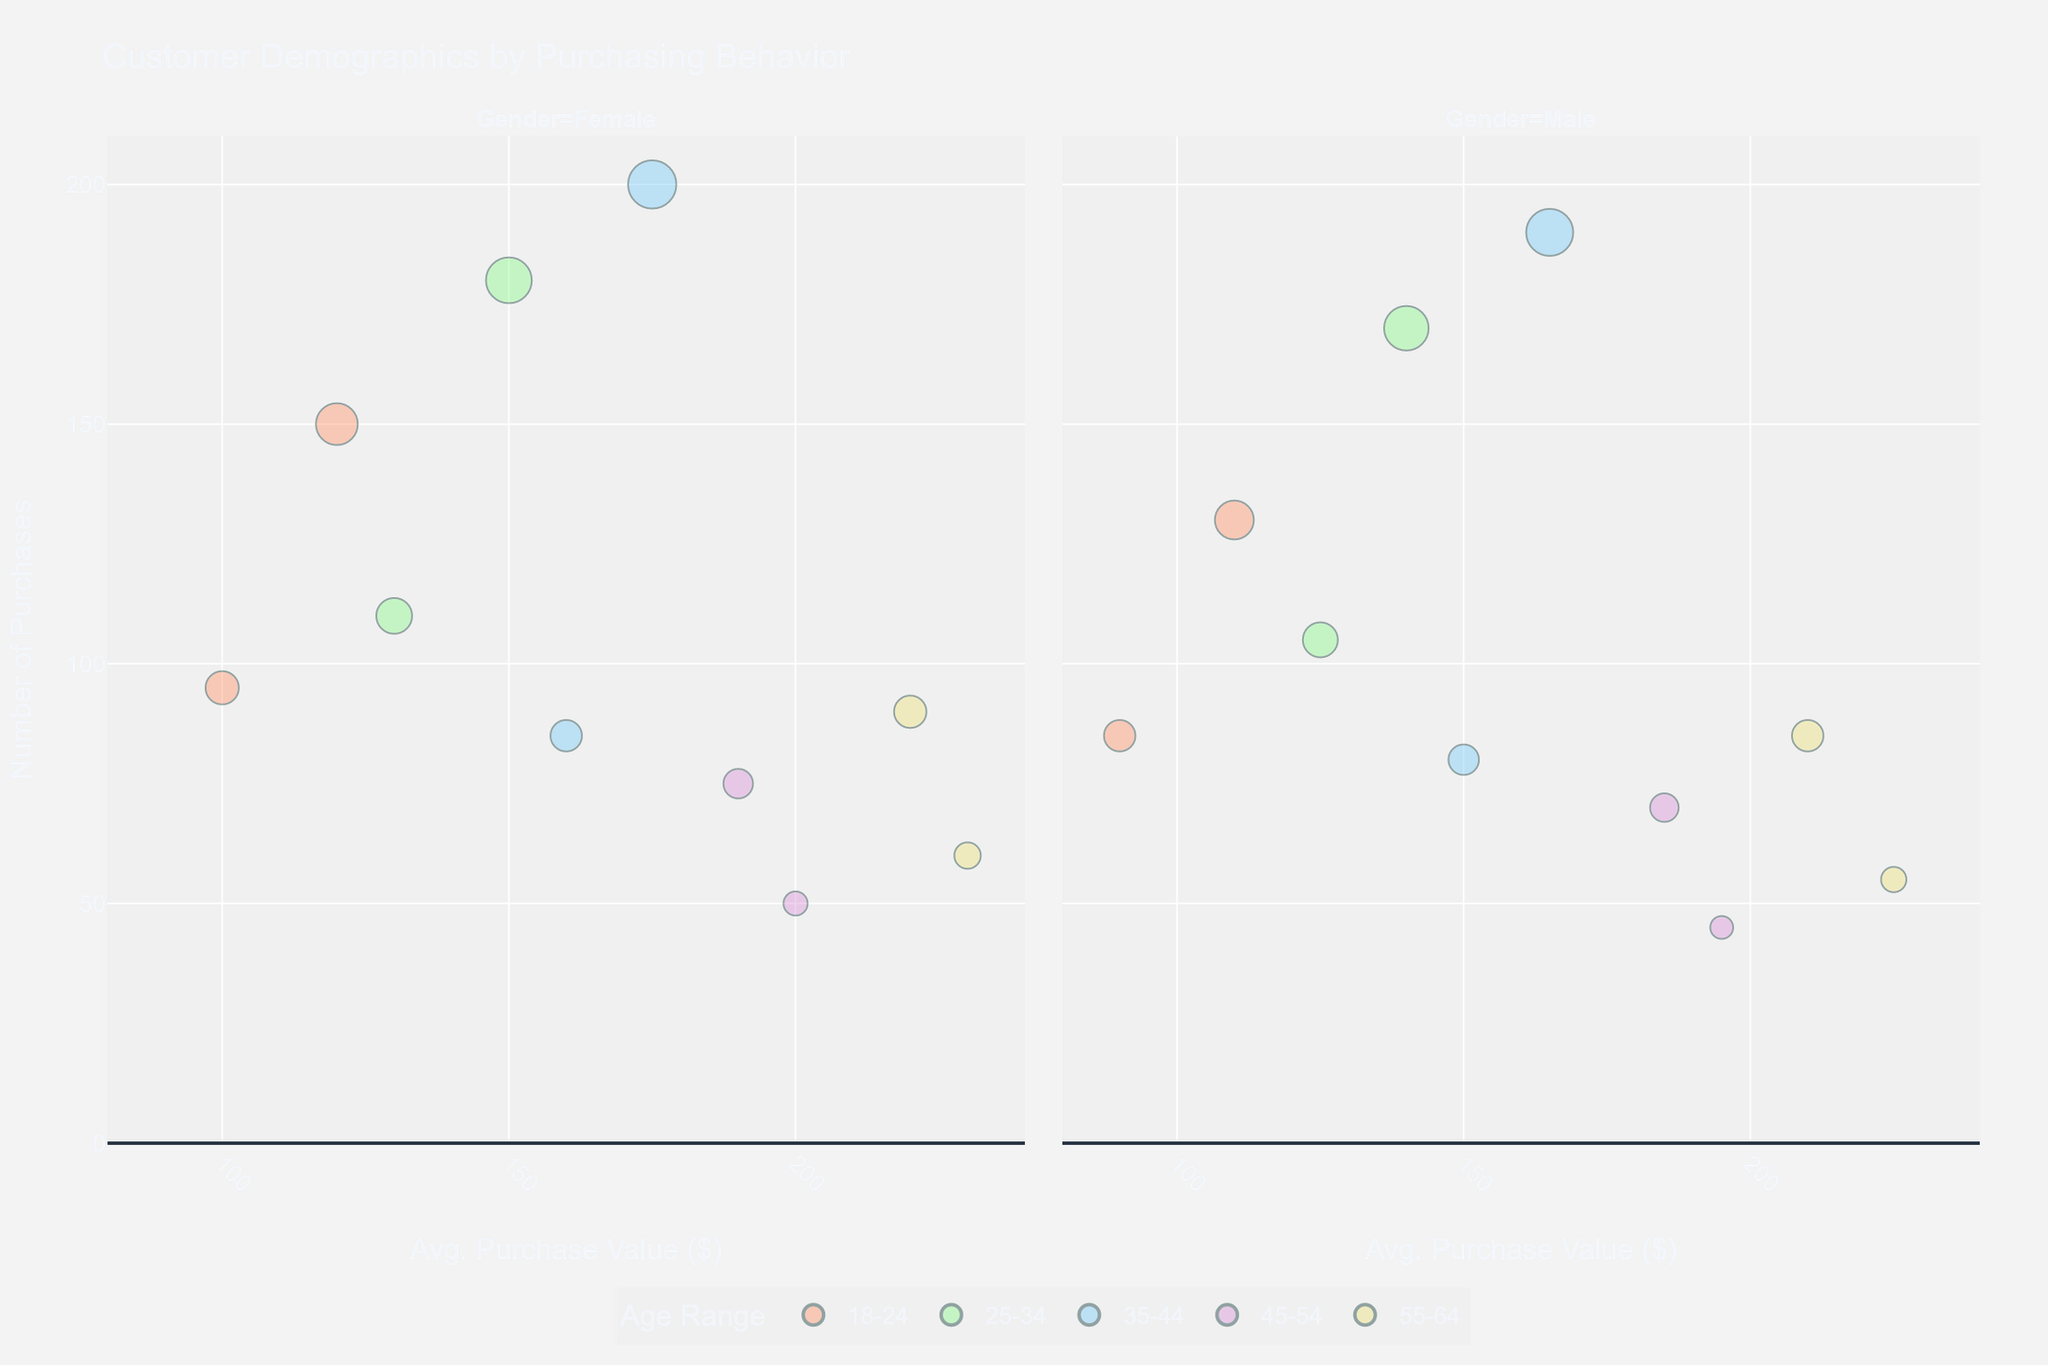What is the title of the figure? The title of the figure is prominently displayed at the top. It reads "Customer Demographics by Purchasing Behavior."
Answer: Customer Demographics by Purchasing Behavior What are the x and y axes representing? The x-axis represents the 'Average Purchase Value ($)' and the y-axis represents the 'Number of Purchases.' This information is labeled clearly on the plot.
Answer: Average Purchase Value ($), Number of Purchases Which age range corresponds to the highest average purchase value for females in the figure? The highest average purchase value for females is indicated by the bubble located furthest to the right in the 'Female' facet. This bubble is in the '55-64' age range, which has an average purchase value of $230.
Answer: 55-64 Which city has the highest number of purchases for males aged 35-44? To find the highest number of purchases for males aged 35-44, locate the largest bubble in the '35-44' age range in the 'Male' facet. The label on the bubble indicates the city, which is Phoenix.
Answer: Phoenix What is the average purchase value difference between males and females aged 18-24 in New York? For this, find the bubbles representing males and females aged 18-24 in New York. The average purchase value for females is $120 and for males is $110. The difference is calculated as $120 - $110 = $10.
Answer: $10 How does the number of purchases for females aged 35-44 in Phoenix compare to males in the same age range and city? Locate the bubbles for females and males aged 35-44 in Phoenix. The bubble for females has 200 purchases, while the bubble for males has 190 purchases. Therefore, females have 10 more purchases than males.
Answer: 10 more purchases for females Which gender has a higher number of purchases on average for the age range 25-34? Identify the bubbles for both genders in the '25-34' age range and average their values. Females have 180 and 110 purchases (average = (180+110)/2 = 145) while males have 170 and 105 purchases (average = (170+105)/2 = 137.5). Females have a higher average.
Answer: Females What is the color code used for the age range 25-34? The color of bubbles representing the '25-34' age range can be seen in the figure. They are shaded in light green.
Answer: Light green How many age ranges are depicted in the figure? Count the unique age range categories represented by different colors in the legend of the figure. There are five age ranges: '18-24', '25-34', '35-44', '45-54', and '55-64.'
Answer: 5 Which gender shows the highest variability in average purchase value across different age ranges? Examine the spread of bubbles for both genders across the x-axis (average purchase value). The 'Female' facet shows a wider spread from around $100 to $230, compared to the 'Male' facet which ranges from $90 to $225. Therefore, females show higher variability.
Answer: Females 